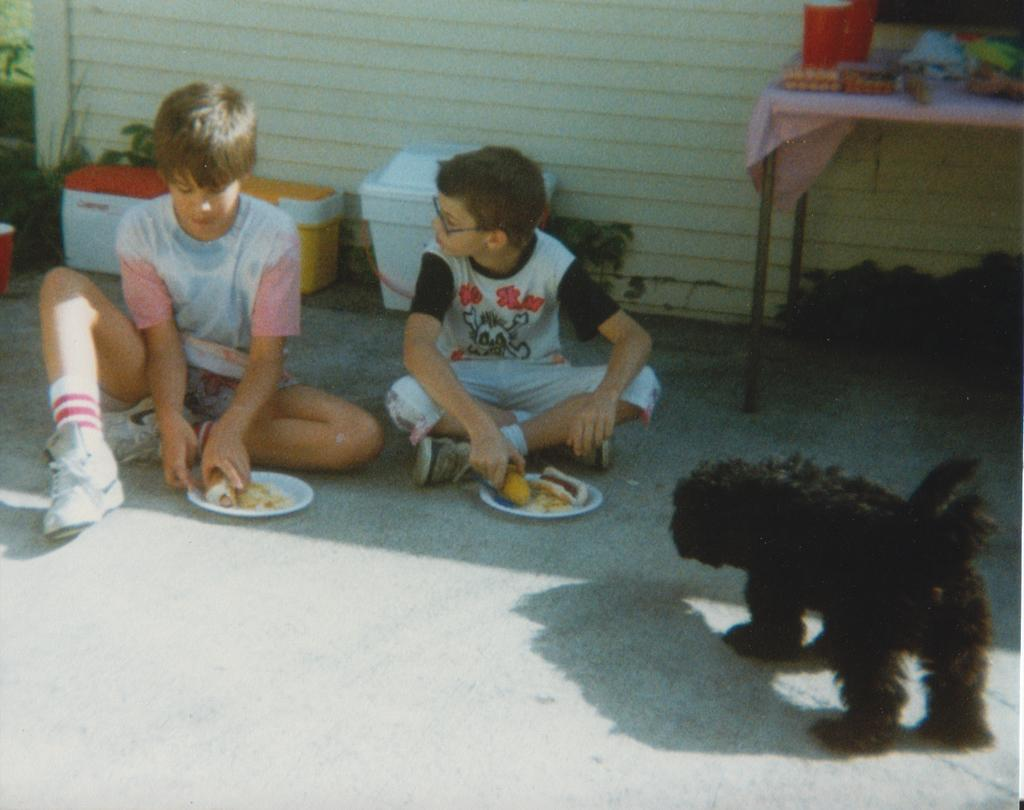What are the people in the image doing? The people in the image are sitting and holding food. How is the food being served in the image? The food is in plates in the image. What can be seen on the wall in the image? There is a wall visible in the image. What type of decoration is present in the image? There are flower pots in the image. What type of animal is in the image? There is a black color dog in the image. What is on the table in the image? There are objects on the table in the image. How does the baby help with the food preparation in the image? There is no baby present in the image, so it cannot help with the food preparation. 